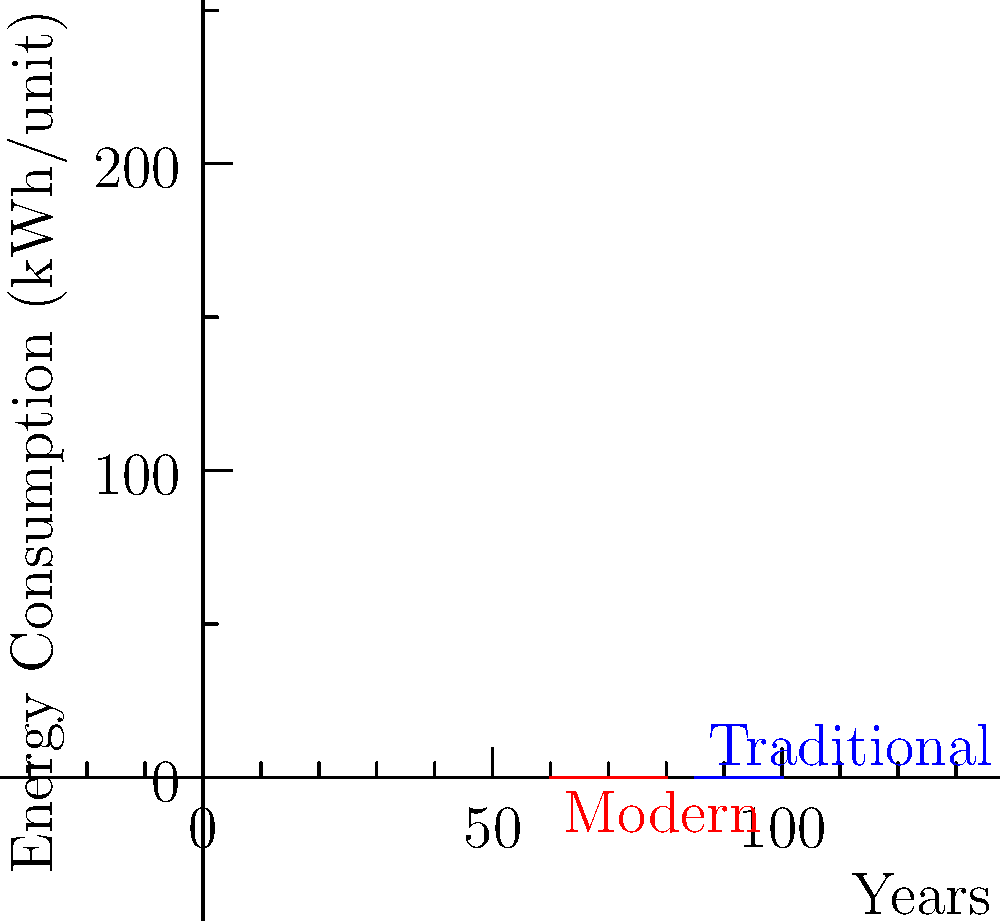As a distributor considering energy efficiency, you're presented with data comparing traditional and modern manufacturing equipment over 5 years. If production remains constant at 10,000 units per year, what's the cumulative energy savings (in kWh) over the 5-year period if you switch to modern equipment? To calculate the cumulative energy savings, we need to:

1. Calculate the energy consumption for each year for both types of equipment:
   Traditional: 100, 95, 90, 88, 85 kWh/unit
   Modern: 80, 70, 65, 62, 60 kWh/unit

2. Multiply each year's consumption by the annual production (10,000 units):
   Traditional (in kWh): 1,000,000, 950,000, 900,000, 880,000, 850,000
   Modern (in kWh): 800,000, 700,000, 650,000, 620,000, 600,000

3. Calculate the difference in energy consumption for each year:
   Year 1: 1,000,000 - 800,000 = 200,000 kWh
   Year 2: 950,000 - 700,000 = 250,000 kWh
   Year 3: 900,000 - 650,000 = 250,000 kWh
   Year 4: 880,000 - 620,000 = 260,000 kWh
   Year 5: 850,000 - 600,000 = 250,000 kWh

4. Sum up the differences to get the cumulative energy savings:
   200,000 + 250,000 + 250,000 + 260,000 + 250,000 = 1,210,000 kWh

Therefore, the cumulative energy savings over the 5-year period is 1,210,000 kWh.
Answer: 1,210,000 kWh 